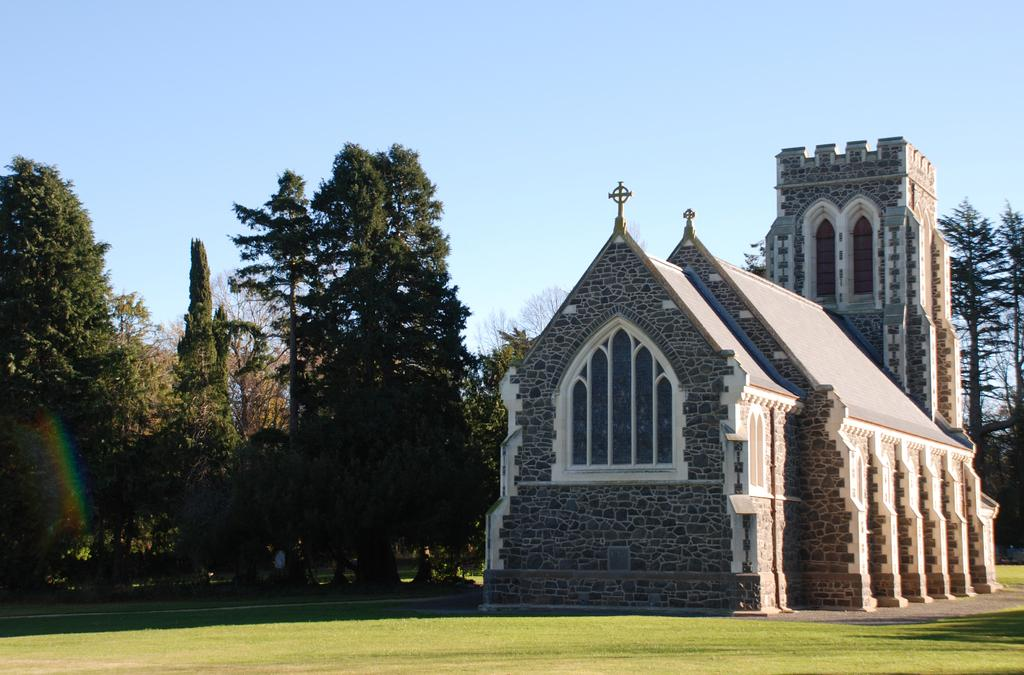What type of building is located on the right side of the image? There is a church on the right side of the image. What can be seen in the middle of the image? There are trees in the middle of the image. What is visible at the top of the image? The sky is visible at the top of the image. What type of pleasure can be seen in the image? There is no pleasure present in the image; it features a church, trees, and the sky. What type of copper object is visible in the image? There is no copper object present in the image. 